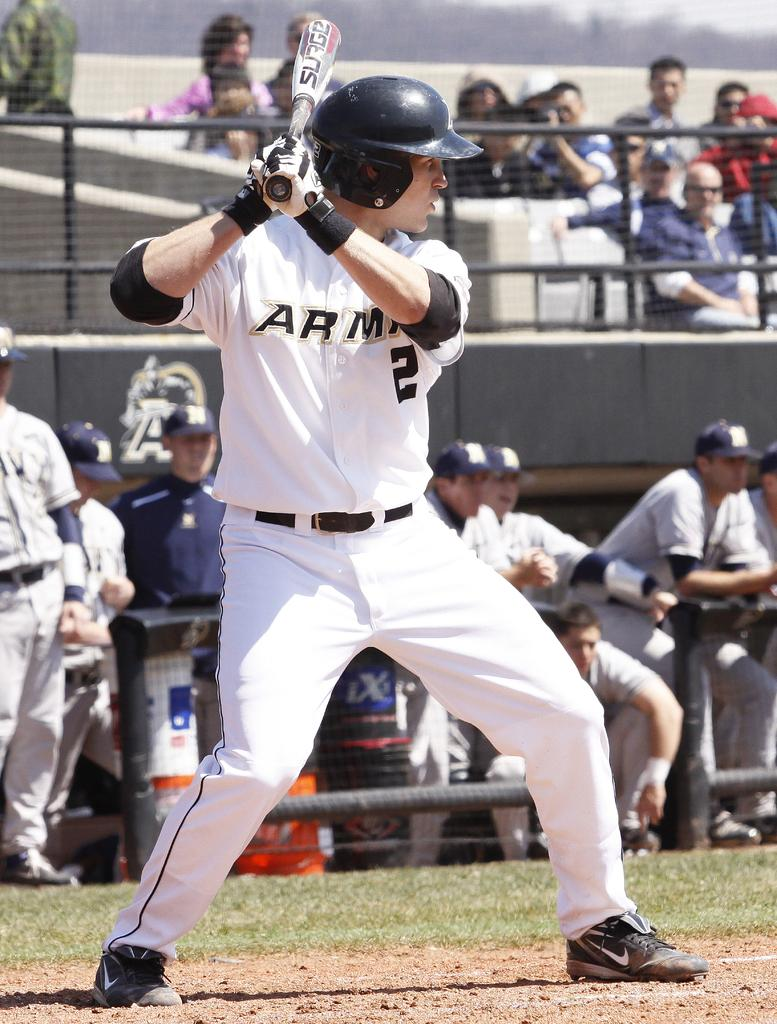<image>
Offer a succinct explanation of the picture presented. A baseball player is holding a bat that has the word surge on it. 